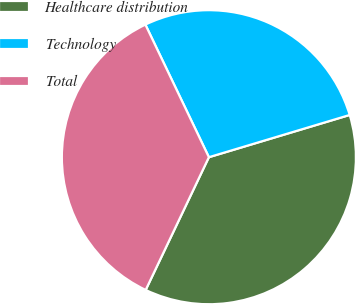Convert chart to OTSL. <chart><loc_0><loc_0><loc_500><loc_500><pie_chart><fcel>Healthcare distribution<fcel>Technology<fcel>Total<nl><fcel>36.71%<fcel>27.47%<fcel>35.82%<nl></chart> 